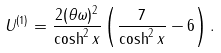<formula> <loc_0><loc_0><loc_500><loc_500>U ^ { ( 1 ) } = \frac { 2 ( \theta \omega ) ^ { 2 } } { \cosh ^ { 2 } x } \left ( \frac { 7 } { \cosh ^ { 2 } x } - 6 \right ) .</formula> 